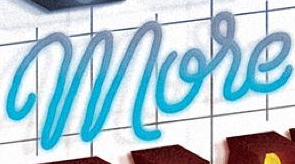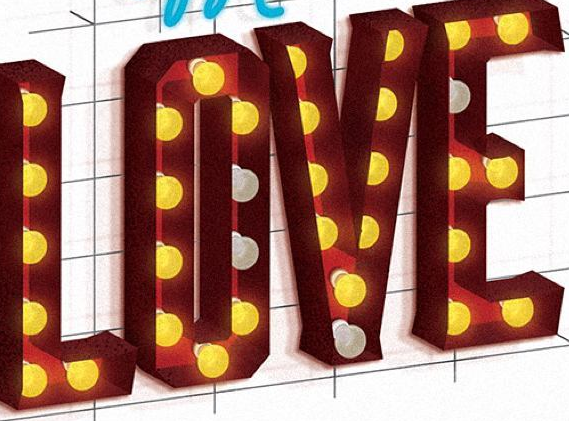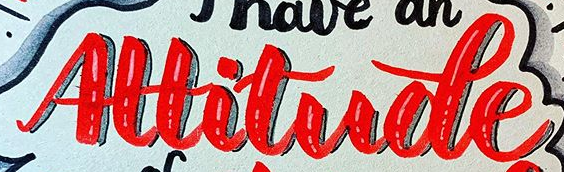Read the text from these images in sequence, separated by a semicolon. More; LOVE; Altitude 